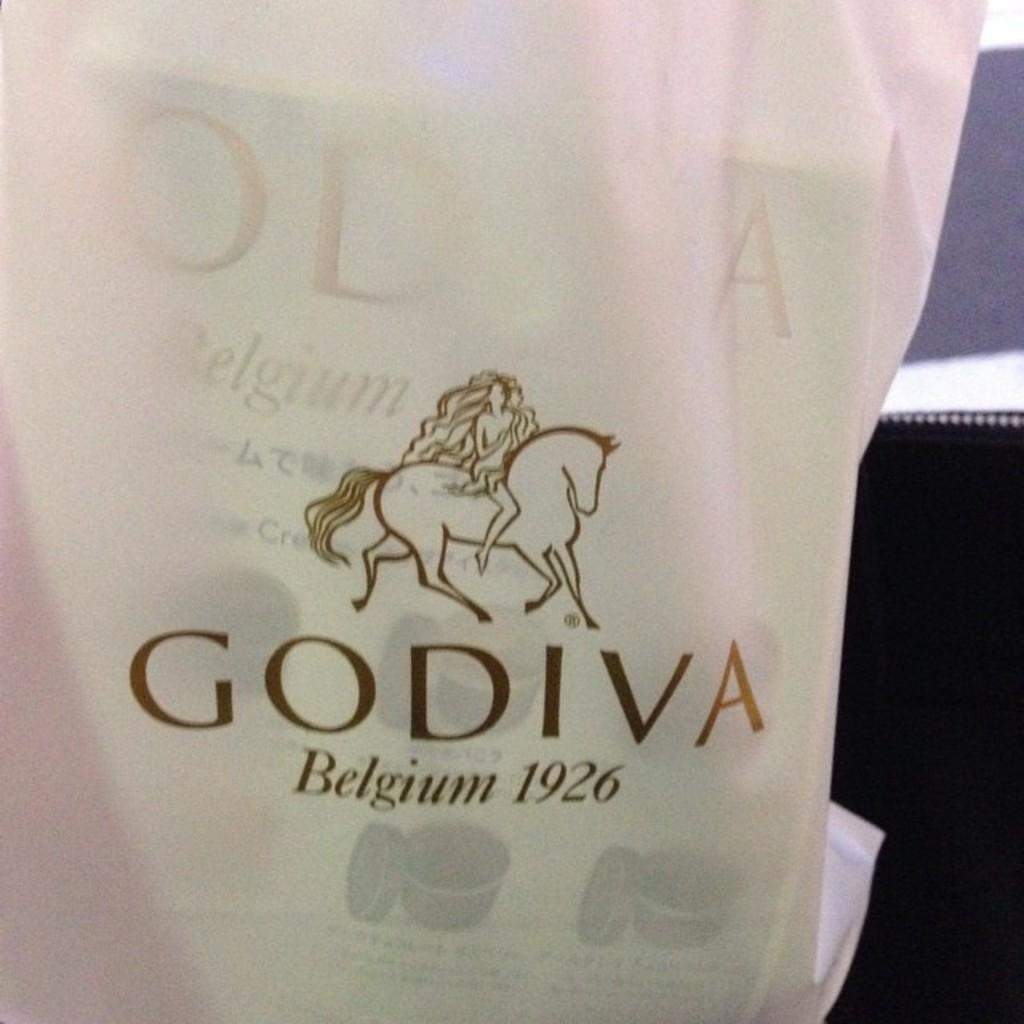<image>
Create a compact narrative representing the image presented. A white Godiva shopping bag with papers in it. 